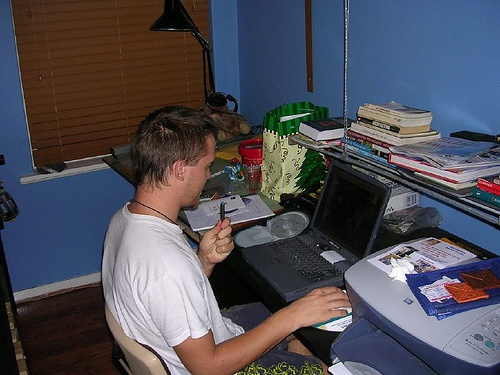Describe the objects in this image and their specific colors. I can see people in darkblue, lightgray, brown, black, and darkgray tones, laptop in darkblue, black, gray, and darkgray tones, book in darkblue, gray, blue, and darkgray tones, book in darkblue and gray tones, and book in darkblue, black, gray, darkgray, and teal tones in this image. 